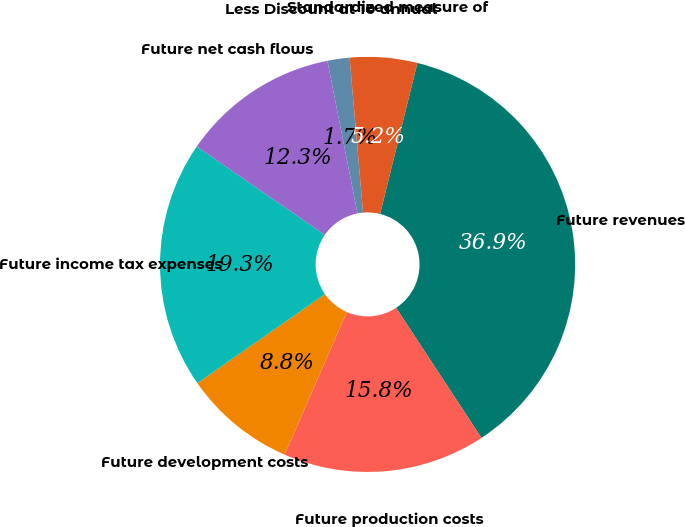Convert chart. <chart><loc_0><loc_0><loc_500><loc_500><pie_chart><fcel>Future revenues<fcel>Future production costs<fcel>Future development costs<fcel>Future income tax expenses<fcel>Future net cash flows<fcel>Less Discount at 10 annual<fcel>Standardized measure of<nl><fcel>36.9%<fcel>15.79%<fcel>8.76%<fcel>19.31%<fcel>12.28%<fcel>1.72%<fcel>5.24%<nl></chart> 